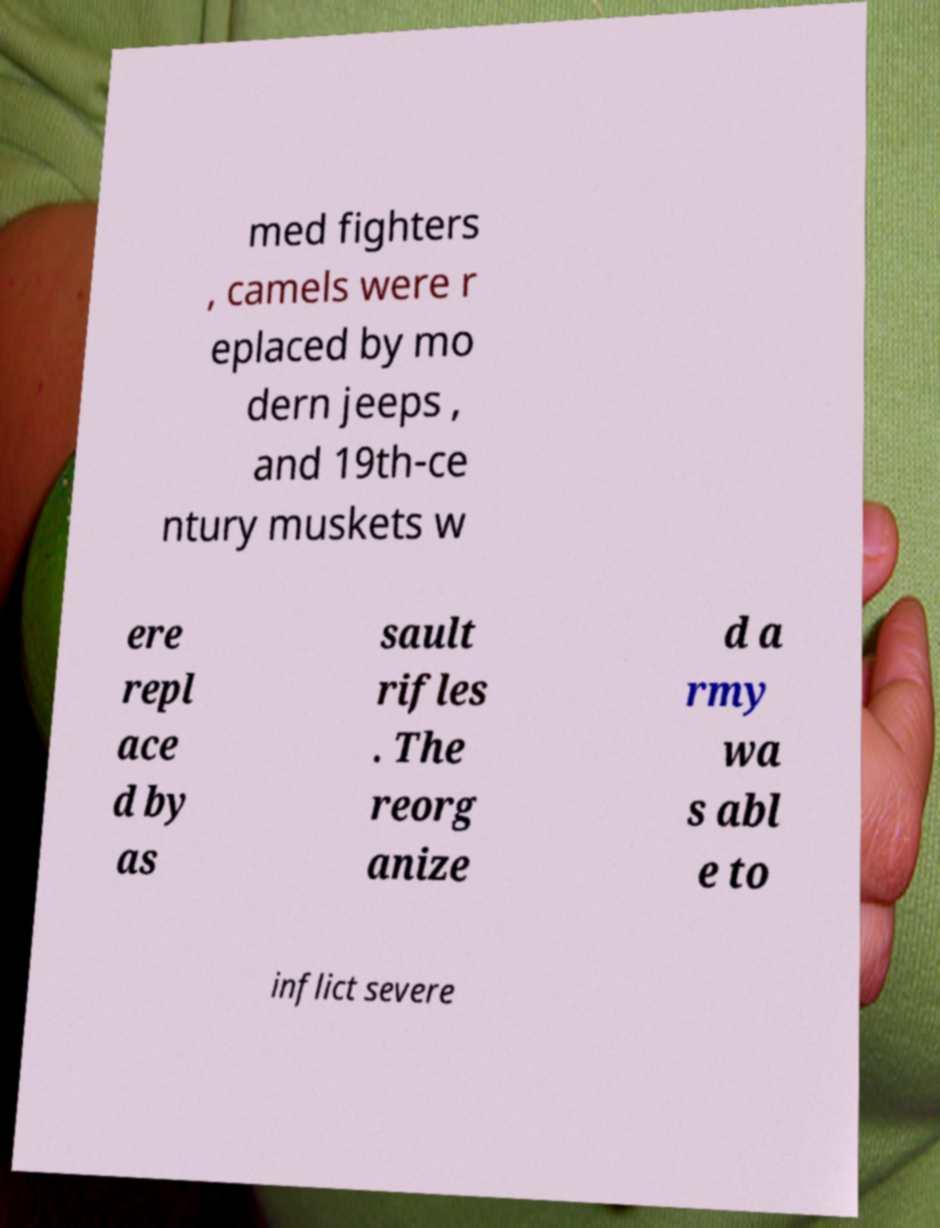Please identify and transcribe the text found in this image. med fighters , camels were r eplaced by mo dern jeeps , and 19th-ce ntury muskets w ere repl ace d by as sault rifles . The reorg anize d a rmy wa s abl e to inflict severe 